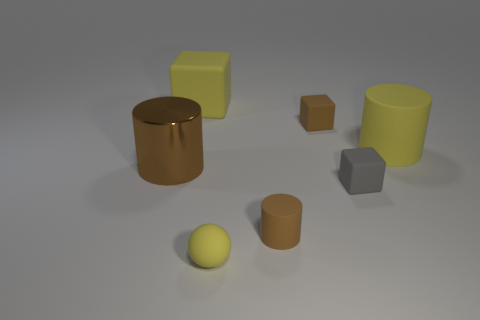Add 3 large yellow metallic cubes. How many objects exist? 10 Subtract all spheres. How many objects are left? 6 Add 6 tiny blue metallic balls. How many tiny blue metallic balls exist? 6 Subtract 2 brown cylinders. How many objects are left? 5 Subtract all brown metallic objects. Subtract all metal things. How many objects are left? 5 Add 4 small gray cubes. How many small gray cubes are left? 5 